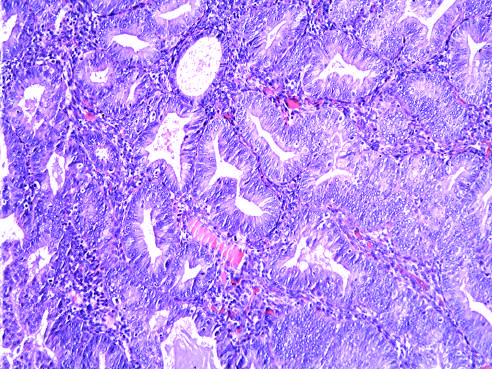s a binucleate reed-sternberg cell with large, inclusion-like nucleoli and abundant cytoplasm seen as glandular crowding and cellular atypia?
Answer the question using a single word or phrase. No 